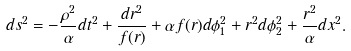<formula> <loc_0><loc_0><loc_500><loc_500>d s ^ { 2 } = - \frac { \rho ^ { 2 } } { \alpha } d t ^ { 2 } + \frac { d r ^ { 2 } } { f ( r ) } + \alpha f ( r ) d \phi _ { 1 } ^ { 2 } + r ^ { 2 } d \phi _ { 2 } ^ { 2 } + \frac { r ^ { 2 } } { \alpha } d x ^ { 2 } .</formula> 